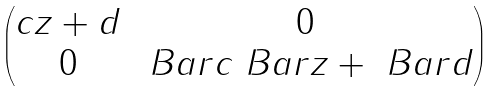Convert formula to latex. <formula><loc_0><loc_0><loc_500><loc_500>\begin{pmatrix} c z + d & 0 \\ 0 & \ B a r { c } \ B a r { z } + \ B a r { d } \end{pmatrix}</formula> 